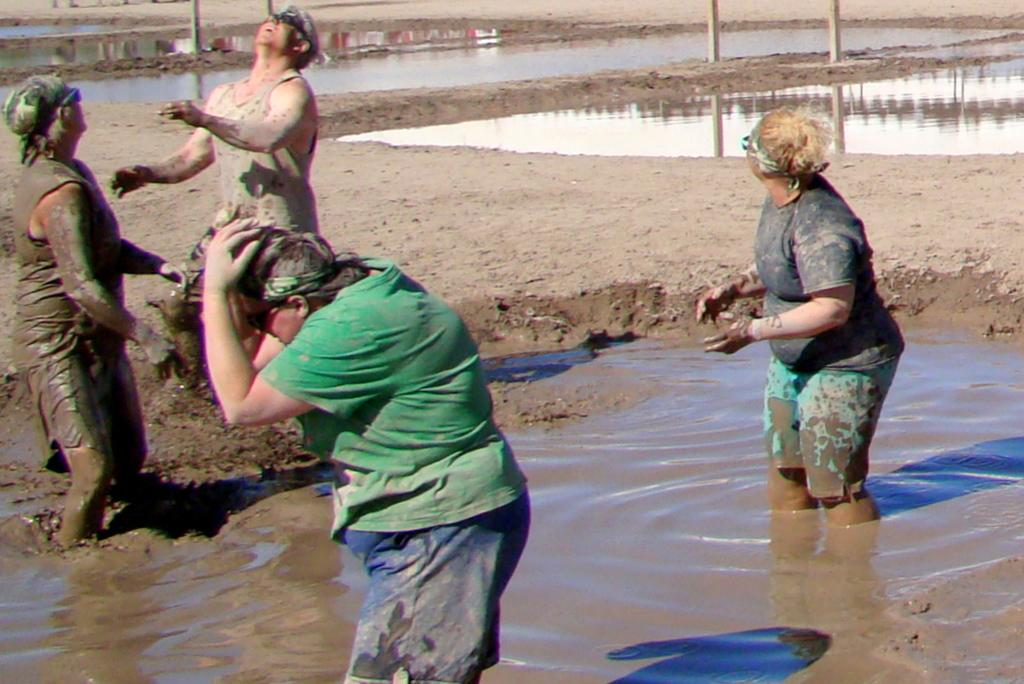How many people are in the image? There are four members in the image. Where are two of them located? Two of them are in the water, and two of them are standing on the mud. What can be seen in the background of the image? There are poles and water visible in the background of the image. What type of yam is being cooked in the image? There is no yam or cooking activity present in the image. What story is being told by the people in the image? The image does not depict a story or any form of communication between the people. 